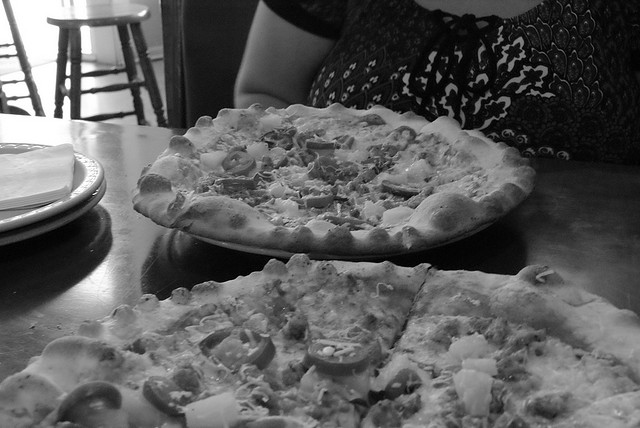<image>What number is on this cake? It is uncertain what number is on this cake. The number could be '2', '1', '0', '5', '3', or there might not be a number at all. What number is on this cake? There is a number on the cake, but I don't know what it is. It can be any number between 0 and 5. 